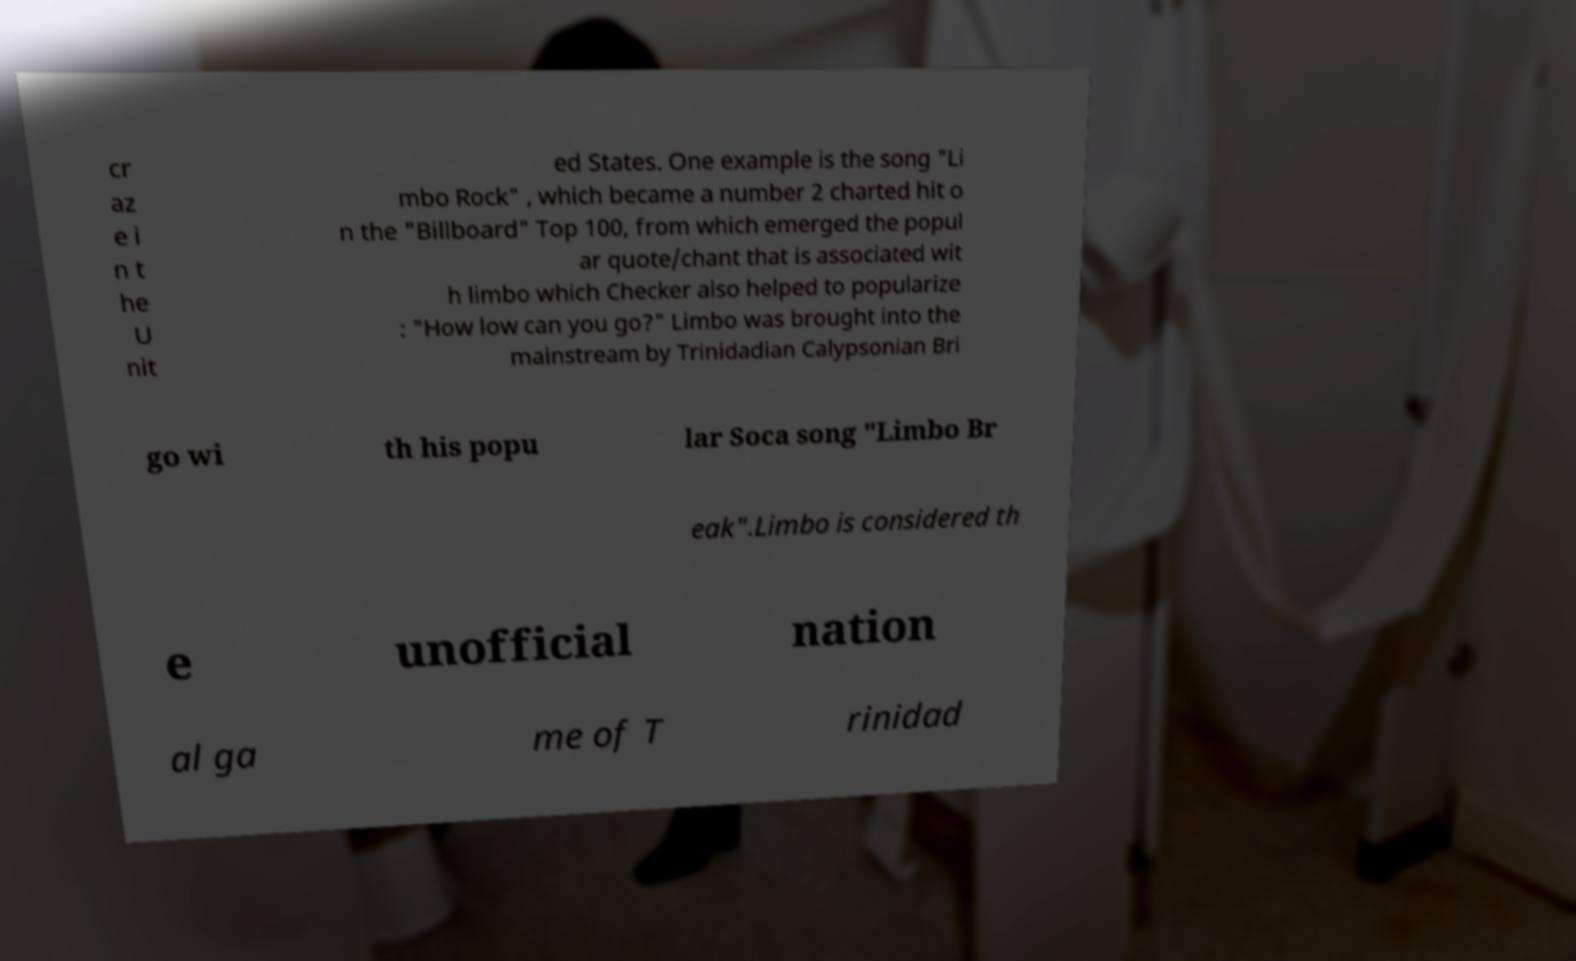Could you extract and type out the text from this image? cr az e i n t he U nit ed States. One example is the song "Li mbo Rock" , which became a number 2 charted hit o n the "Billboard" Top 100, from which emerged the popul ar quote/chant that is associated wit h limbo which Checker also helped to popularize : "How low can you go?" Limbo was brought into the mainstream by Trinidadian Calypsonian Bri go wi th his popu lar Soca song "Limbo Br eak".Limbo is considered th e unofficial nation al ga me of T rinidad 